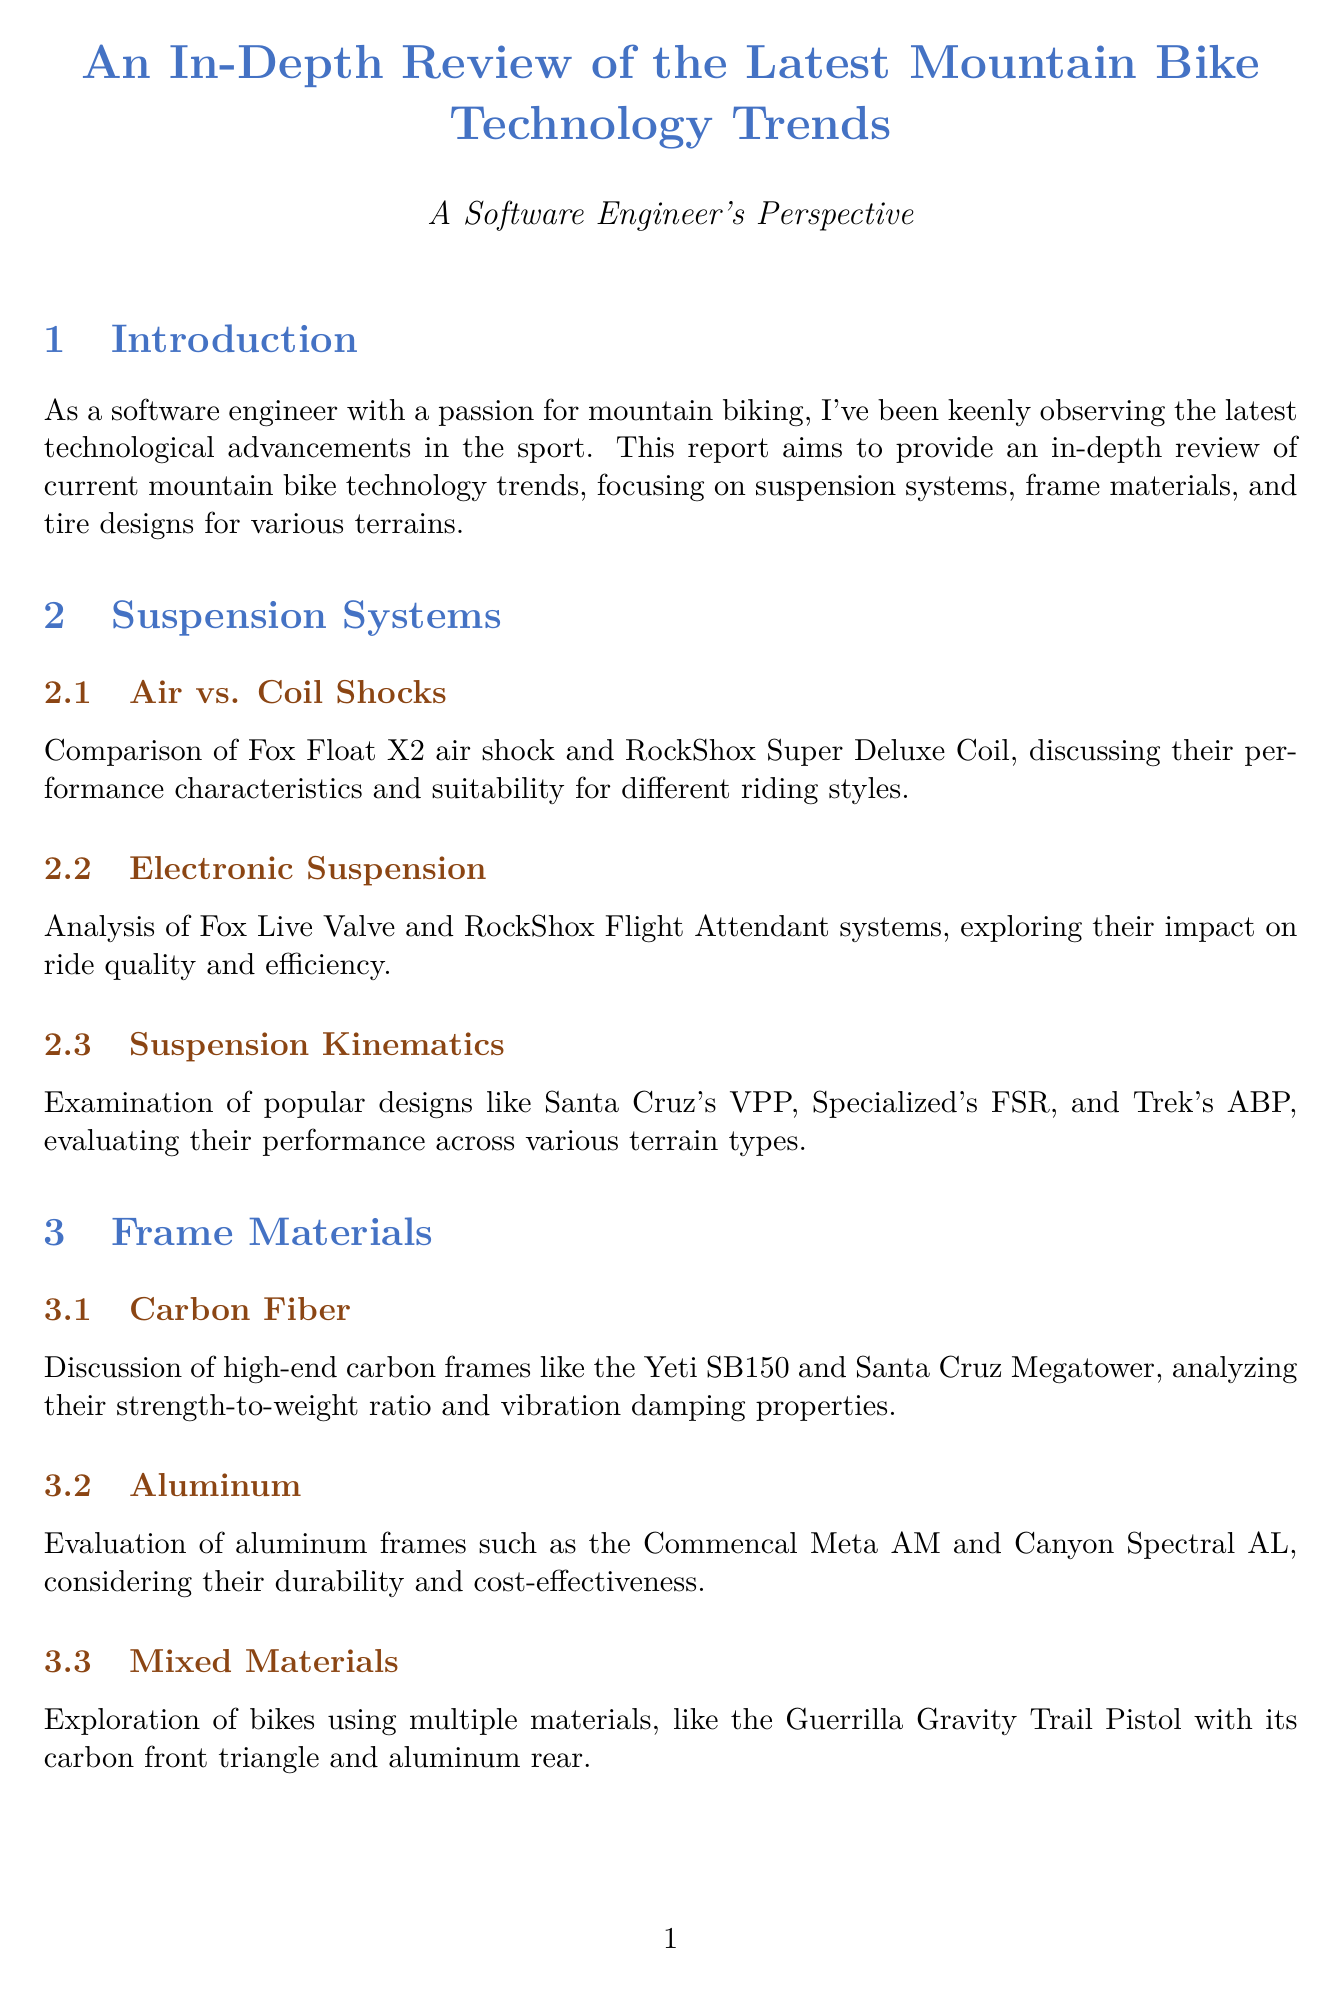What is the focus of the report? The report aims to provide an in-depth review of current mountain bike technology trends, specifically looking at suspension systems, frame materials, and tire designs for various terrains.
Answer: Suspension systems, frame materials, and tire designs Who conducted the expert interview about carbon fiber frame design? The document states that Steve Mathews, Lead Engineer at Santa Cruz Bicycles, discussed the future of carbon fiber frame design.
Answer: Steve Mathews What type of tires are compared in the tread patterns section? The tread patterns section compares aggressive all-mountain tires with faster-rolling XC tires.
Answer: Aggressive all-mountain tires and faster-rolling XC tires Which technology is analyzed for its impact on ride quality? The document mentions the analysis of Fox Live Valve and RockShox Flight Attendant systems in relation to ride quality.
Answer: Fox Live Valve and RockShox Flight Attendant What is one of the main advantages of tubeless tire systems mentioned? The overview of tubeless tire technology discusses benefits such as reduced puncture occurrences and improved performance.
Answer: Reduced puncture occurrences What is the market share pie chart showing? The frame material market share pie chart shows the distribution of frame materials like carbon, aluminum, steel, and titanium in the market.
Answer: Distribution of frame materials What two materials are combined in the Guerrilla Gravity Trail Pistol? The document states that the Guerrilla Gravity Trail Pistol features a carbon front triangle and aluminum rear.
Answer: Carbon front triangle and aluminum rear How many case studies are included in the report? The document lists two case studies: one on Enduro World Series Tech and another on Cross-Country Olympic Innovations.
Answer: Two 